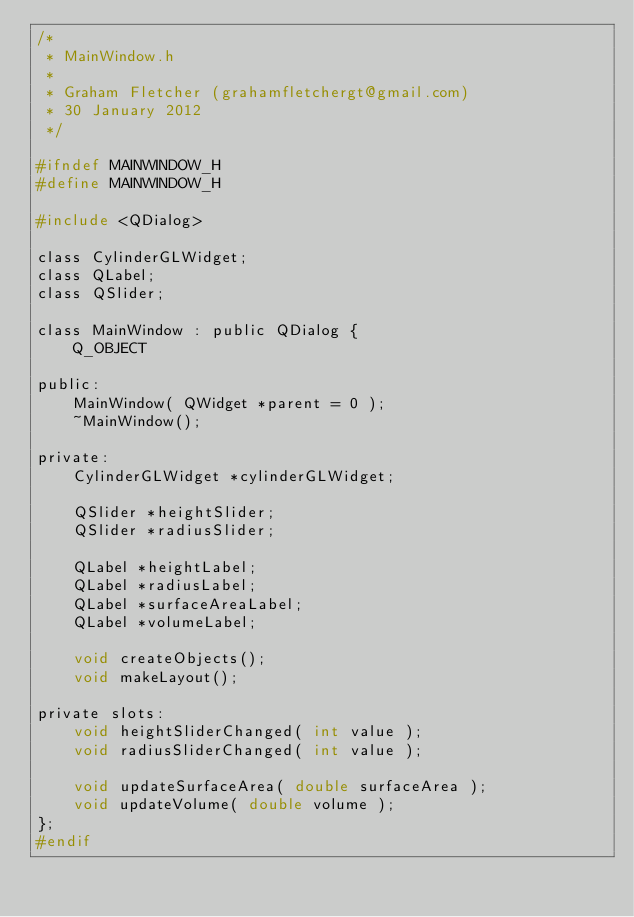Convert code to text. <code><loc_0><loc_0><loc_500><loc_500><_C_>/*
 * MainWindow.h
 *
 * Graham Fletcher (grahamfletchergt@gmail.com)
 * 30 January 2012
 */

#ifndef MAINWINDOW_H
#define MAINWINDOW_H

#include <QDialog>

class CylinderGLWidget;
class QLabel;
class QSlider;

class MainWindow : public QDialog {
    Q_OBJECT

public:
    MainWindow( QWidget *parent = 0 );
    ~MainWindow();

private:
    CylinderGLWidget *cylinderGLWidget;

    QSlider *heightSlider;
    QSlider *radiusSlider;

    QLabel *heightLabel;
    QLabel *radiusLabel;
    QLabel *surfaceAreaLabel;
    QLabel *volumeLabel;

    void createObjects();
    void makeLayout();

private slots:
    void heightSliderChanged( int value );
    void radiusSliderChanged( int value );

    void updateSurfaceArea( double surfaceArea );
    void updateVolume( double volume );
};
#endif
</code> 